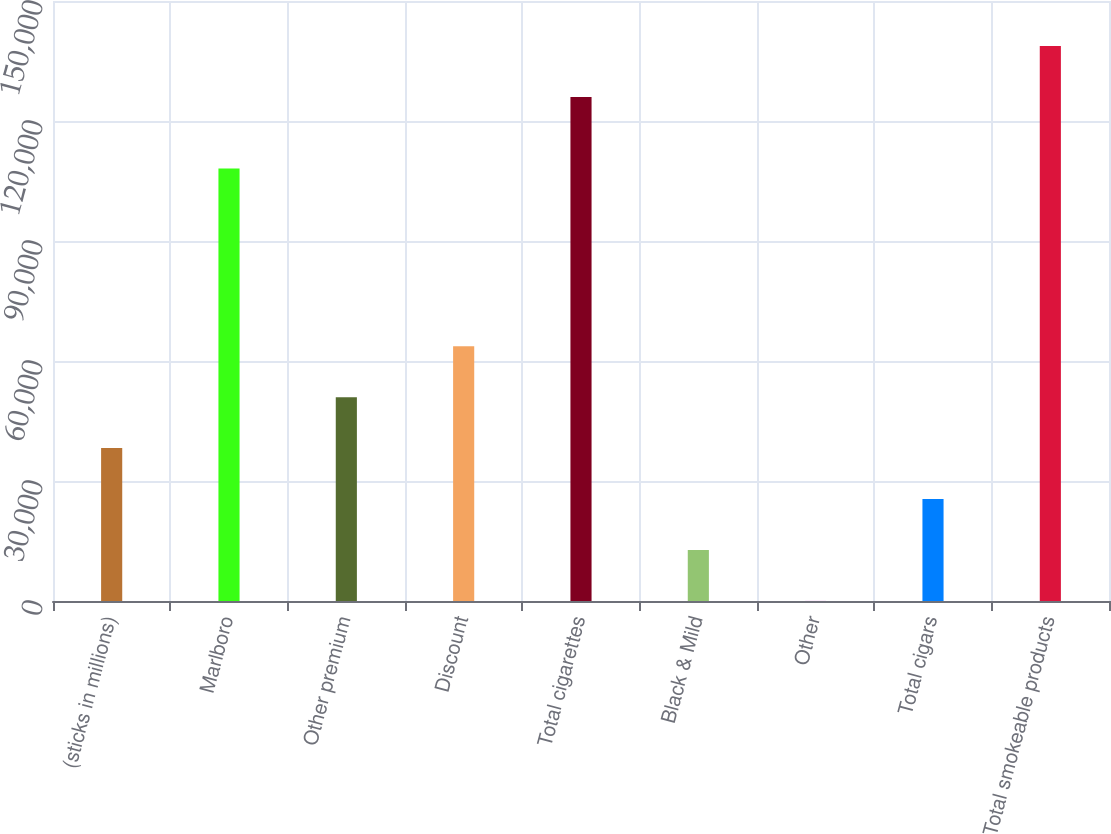Convert chart. <chart><loc_0><loc_0><loc_500><loc_500><bar_chart><fcel>(sticks in millions)<fcel>Marlboro<fcel>Other premium<fcel>Discount<fcel>Total cigarettes<fcel>Black & Mild<fcel>Other<fcel>Total cigars<fcel>Total smokeable products<nl><fcel>38223.9<fcel>108113<fcel>50955.2<fcel>63686.5<fcel>126018<fcel>12761.3<fcel>30<fcel>25492.6<fcel>138749<nl></chart> 